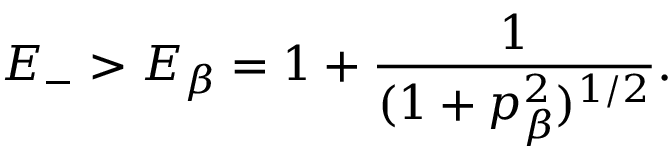<formula> <loc_0><loc_0><loc_500><loc_500>E _ { - } > E _ { \beta } = 1 + \frac { 1 } { ( 1 + p _ { \beta } ^ { 2 } ) ^ { 1 / 2 } } .</formula> 